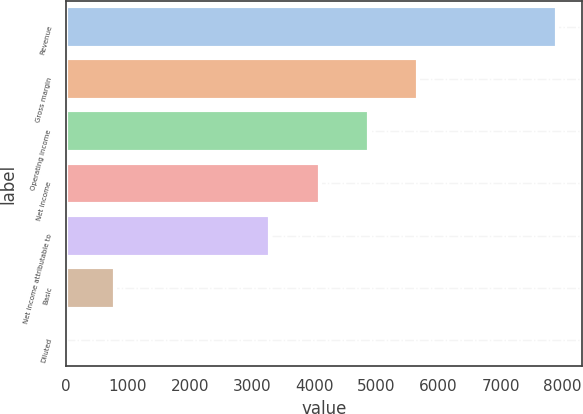<chart> <loc_0><loc_0><loc_500><loc_500><bar_chart><fcel>Revenue<fcel>Gross margin<fcel>Operating income<fcel>Net income<fcel>Net income attributable to<fcel>Basic<fcel>Diluted<nl><fcel>7913<fcel>5666.06<fcel>4875.04<fcel>4084.02<fcel>3293<fcel>793.83<fcel>2.81<nl></chart> 